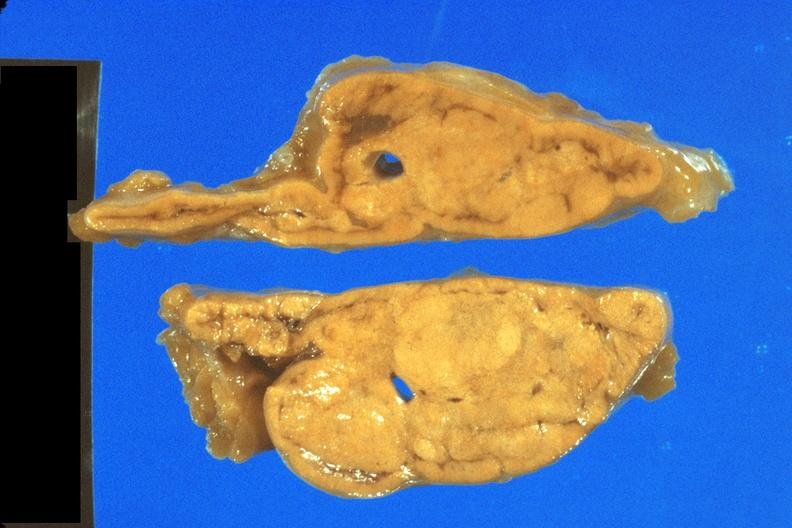where does this belong to?
Answer the question using a single word or phrase. Endocrine system 